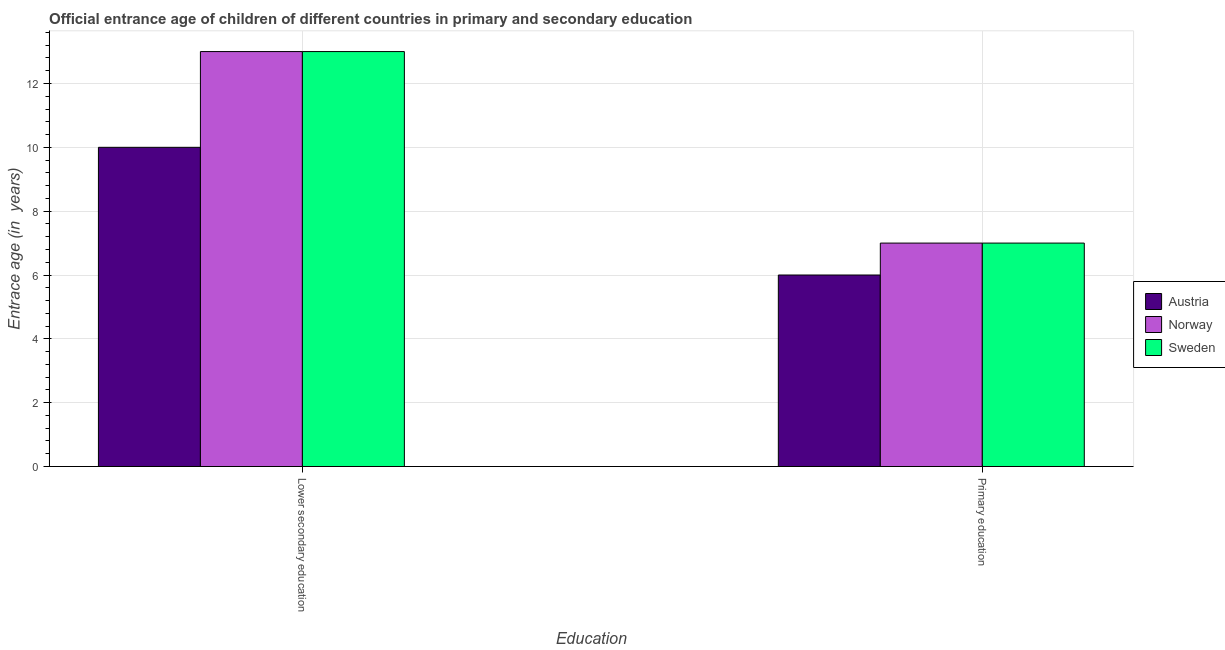How many groups of bars are there?
Your answer should be very brief. 2. Are the number of bars per tick equal to the number of legend labels?
Your answer should be compact. Yes. How many bars are there on the 2nd tick from the left?
Make the answer very short. 3. What is the label of the 1st group of bars from the left?
Ensure brevity in your answer.  Lower secondary education. What is the entrance age of children in lower secondary education in Sweden?
Provide a short and direct response. 13. Across all countries, what is the maximum entrance age of children in lower secondary education?
Your response must be concise. 13. Across all countries, what is the minimum entrance age of children in lower secondary education?
Give a very brief answer. 10. What is the total entrance age of children in lower secondary education in the graph?
Your answer should be very brief. 36. What is the difference between the entrance age of chiildren in primary education in Austria and that in Norway?
Make the answer very short. -1. What is the ratio of the entrance age of chiildren in primary education in Norway to that in Austria?
Make the answer very short. 1.17. Is the entrance age of chiildren in primary education in Sweden less than that in Austria?
Ensure brevity in your answer.  No. What does the 1st bar from the left in Lower secondary education represents?
Provide a succinct answer. Austria. Are the values on the major ticks of Y-axis written in scientific E-notation?
Keep it short and to the point. No. Where does the legend appear in the graph?
Ensure brevity in your answer.  Center right. How many legend labels are there?
Your answer should be compact. 3. How are the legend labels stacked?
Offer a terse response. Vertical. What is the title of the graph?
Your answer should be compact. Official entrance age of children of different countries in primary and secondary education. What is the label or title of the X-axis?
Your response must be concise. Education. What is the label or title of the Y-axis?
Provide a succinct answer. Entrace age (in  years). What is the Entrace age (in  years) of Austria in Lower secondary education?
Keep it short and to the point. 10. What is the Entrace age (in  years) in Norway in Lower secondary education?
Your answer should be very brief. 13. What is the Entrace age (in  years) in Austria in Primary education?
Ensure brevity in your answer.  6. What is the Entrace age (in  years) in Norway in Primary education?
Your response must be concise. 7. What is the Entrace age (in  years) in Sweden in Primary education?
Your answer should be compact. 7. Across all Education, what is the maximum Entrace age (in  years) in Austria?
Give a very brief answer. 10. Across all Education, what is the maximum Entrace age (in  years) in Norway?
Ensure brevity in your answer.  13. Across all Education, what is the minimum Entrace age (in  years) in Austria?
Offer a terse response. 6. Across all Education, what is the minimum Entrace age (in  years) of Norway?
Provide a short and direct response. 7. Across all Education, what is the minimum Entrace age (in  years) of Sweden?
Keep it short and to the point. 7. What is the total Entrace age (in  years) in Austria in the graph?
Offer a terse response. 16. What is the difference between the Entrace age (in  years) of Austria in Lower secondary education and that in Primary education?
Your answer should be very brief. 4. What is the difference between the Entrace age (in  years) in Norway in Lower secondary education and that in Primary education?
Offer a terse response. 6. What is the difference between the Entrace age (in  years) in Sweden in Lower secondary education and that in Primary education?
Give a very brief answer. 6. What is the difference between the Entrace age (in  years) in Austria in Lower secondary education and the Entrace age (in  years) in Sweden in Primary education?
Offer a terse response. 3. What is the difference between the Entrace age (in  years) of Norway in Lower secondary education and the Entrace age (in  years) of Sweden in Primary education?
Ensure brevity in your answer.  6. What is the average Entrace age (in  years) in Norway per Education?
Your answer should be very brief. 10. What is the difference between the Entrace age (in  years) in Austria and Entrace age (in  years) in Norway in Lower secondary education?
Ensure brevity in your answer.  -3. What is the difference between the Entrace age (in  years) of Austria and Entrace age (in  years) of Sweden in Lower secondary education?
Offer a terse response. -3. What is the difference between the Entrace age (in  years) of Norway and Entrace age (in  years) of Sweden in Lower secondary education?
Your answer should be compact. 0. What is the difference between the Entrace age (in  years) of Austria and Entrace age (in  years) of Norway in Primary education?
Offer a very short reply. -1. What is the ratio of the Entrace age (in  years) in Norway in Lower secondary education to that in Primary education?
Provide a short and direct response. 1.86. What is the ratio of the Entrace age (in  years) in Sweden in Lower secondary education to that in Primary education?
Provide a short and direct response. 1.86. What is the difference between the highest and the second highest Entrace age (in  years) in Sweden?
Make the answer very short. 6. What is the difference between the highest and the lowest Entrace age (in  years) of Austria?
Ensure brevity in your answer.  4. 